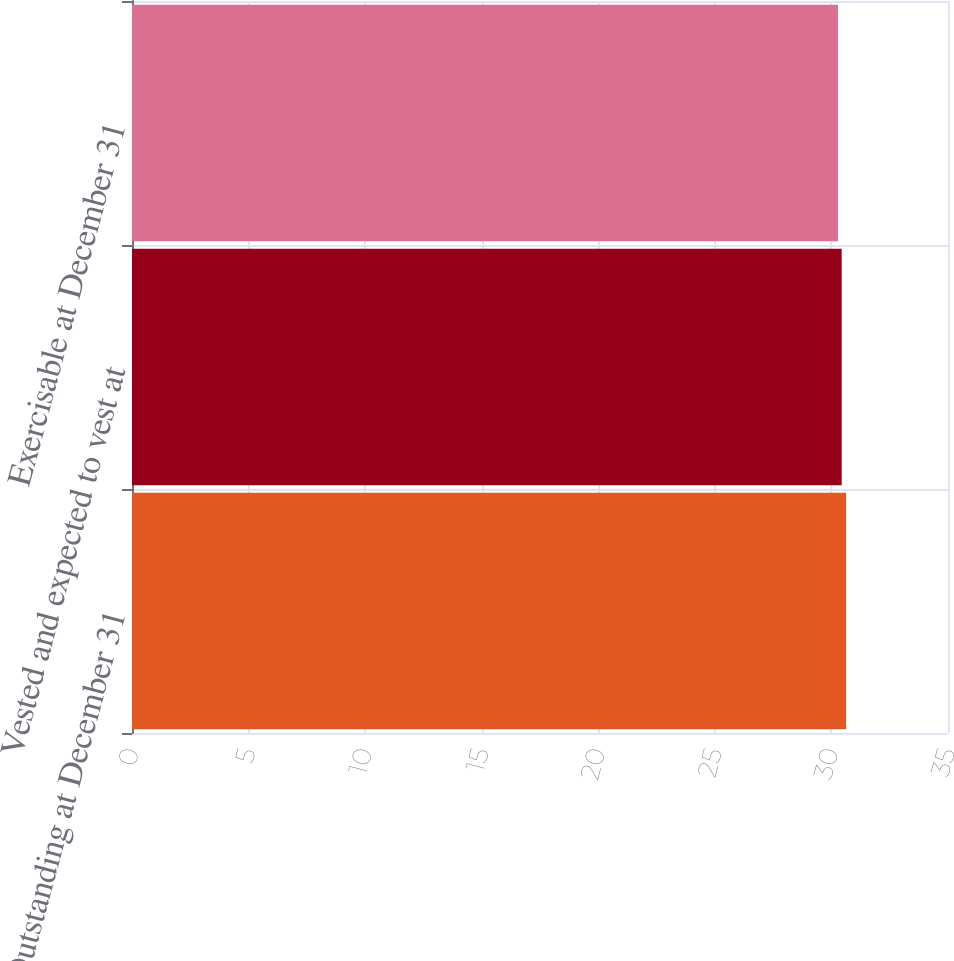Convert chart. <chart><loc_0><loc_0><loc_500><loc_500><bar_chart><fcel>Outstanding at December 31<fcel>Vested and expected to vest at<fcel>Exercisable at December 31<nl><fcel>30.63<fcel>30.44<fcel>30.28<nl></chart> 